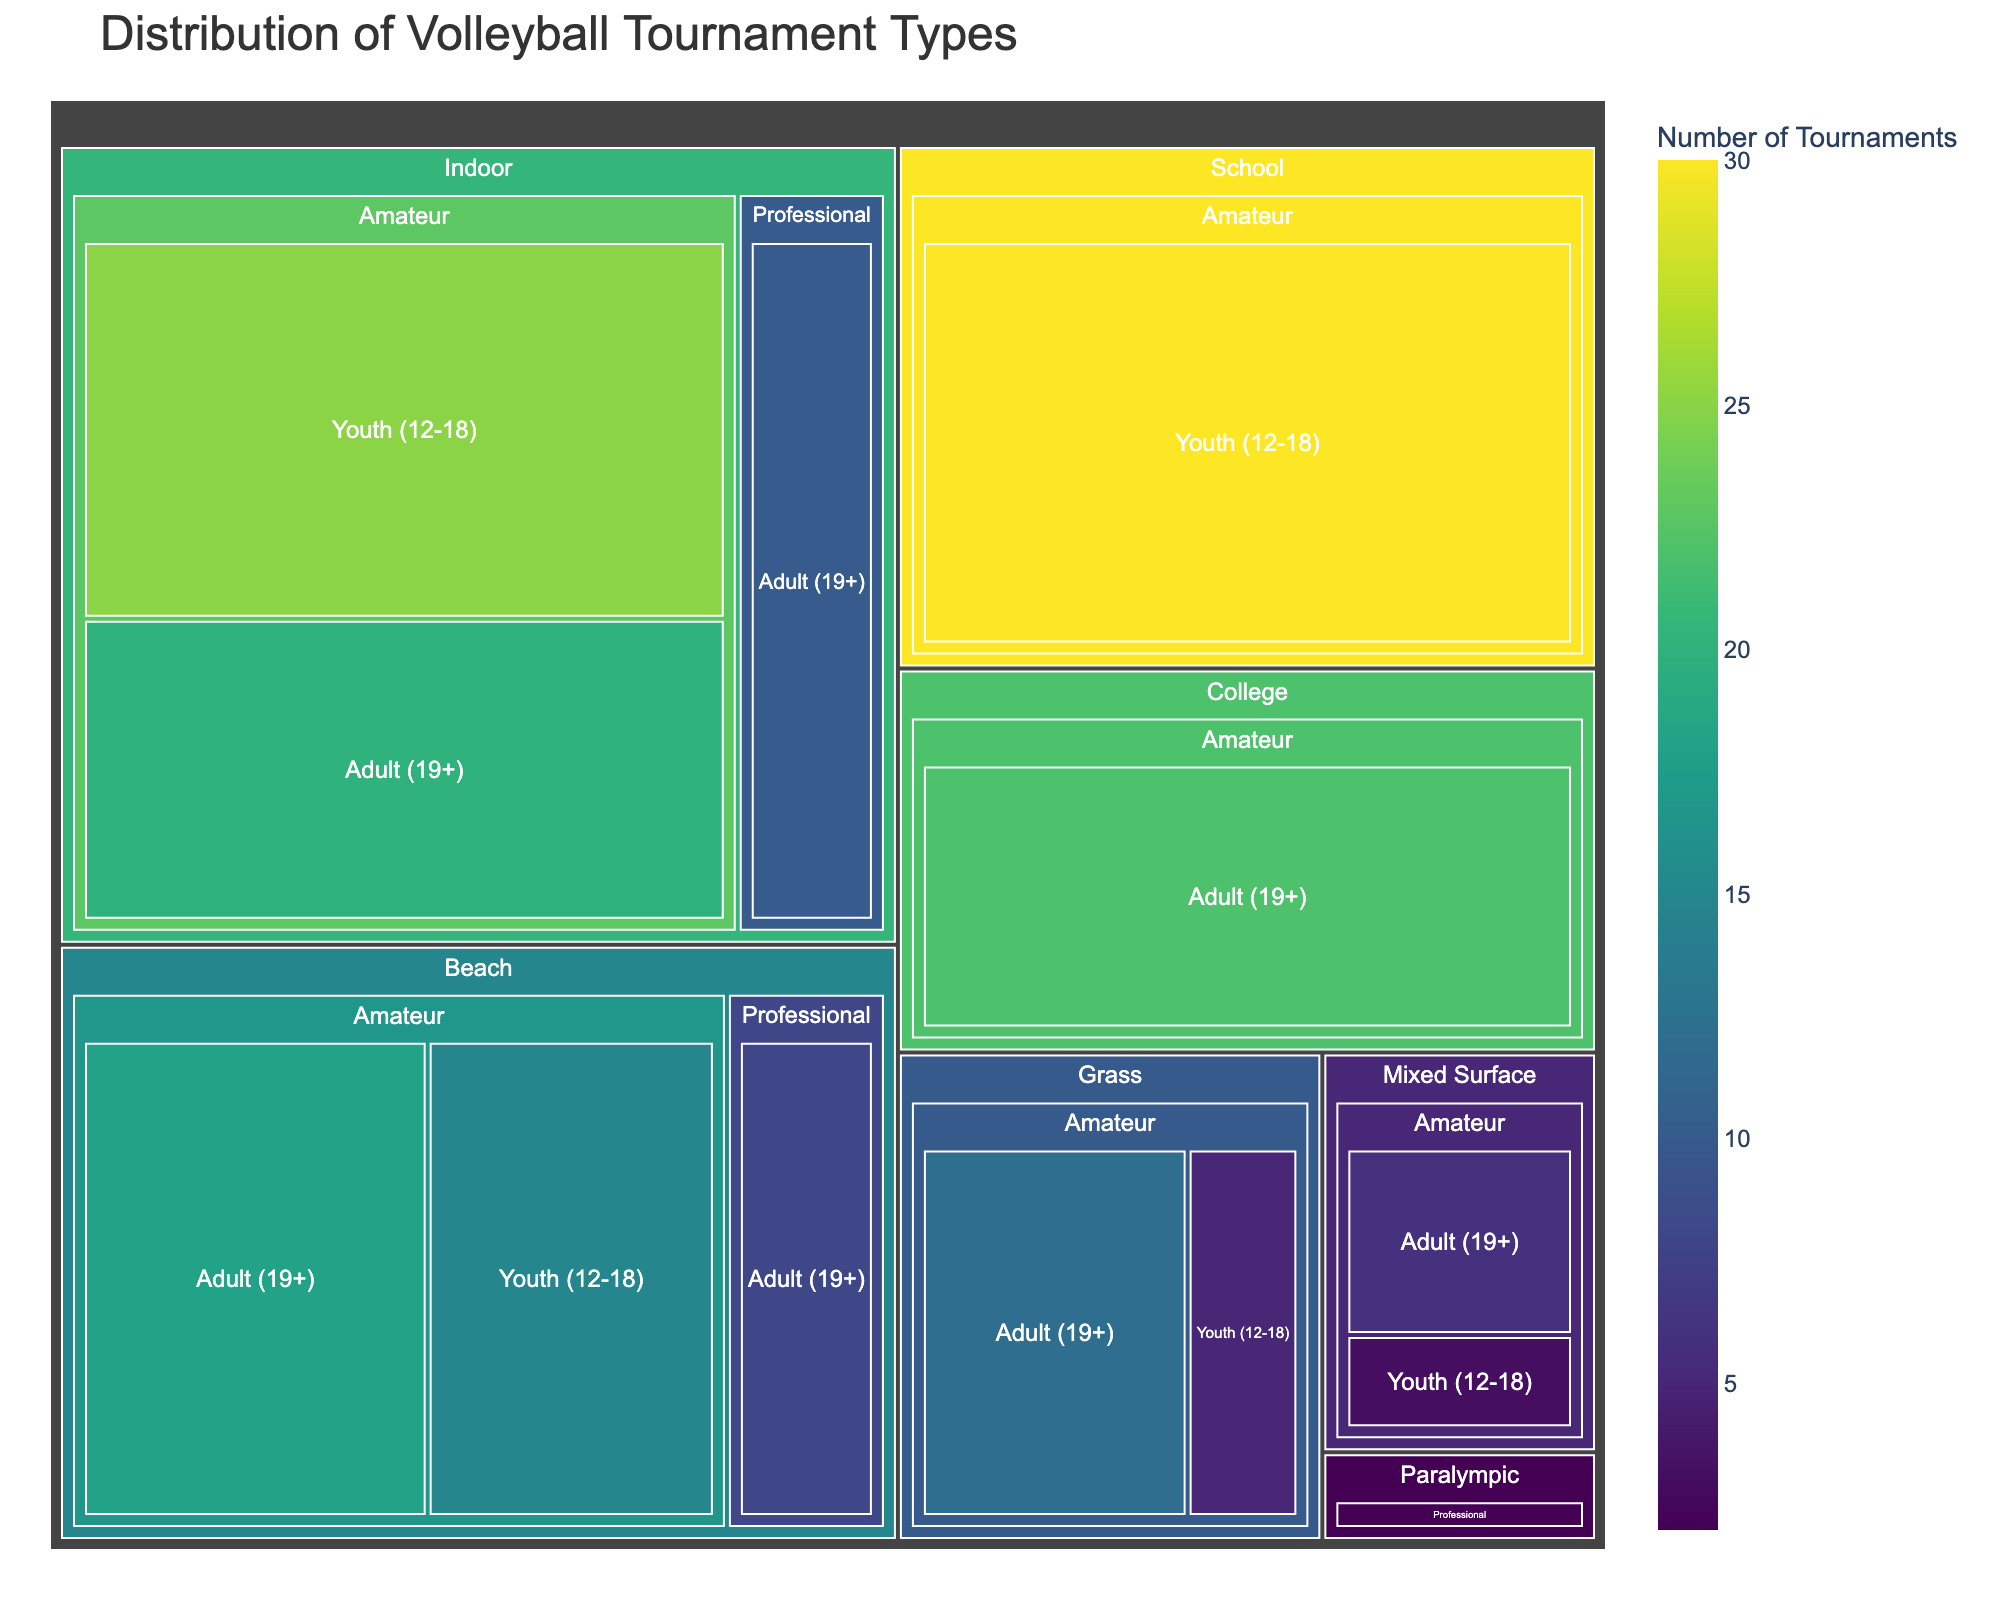What is the title of the figure? The title of the figure is usually displayed prominently at the top and serves to give an overview of what the figure represents. In this case, it can be directly read from the top of the figure.
Answer: Distribution of Volleyball Tournament Types Which age group has the highest number of tournaments for Indoor Amateur type? To find this, locate the "Indoor" section, then find the "Amateur" subsection and check the "Number of Tournaments" for both "Youth (12-18)" and "Adult (19+)". Compare the numbers.
Answer: Youth (12-18) What is the total number of Professional tournaments across all types? Sum the number of Professional tournaments for each type. Look at all sections (Indoor, Beach, Paralympic) that have "Professional" and add their values. Calculation: Indoor (10) + Beach (8) + Paralympic (2) = 20.
Answer: 20 Which participation level has the most number of tournaments overall? Sum the number of tournaments for each participation level across all tournament types and age groups. Compare the totals for "Amateur" and "Professional". The figure shows more extensive "Amateur" tournaments distributed across various types.
Answer: Amateur How many tournaments are held in Mixed Surface for Youth (12-18)? Locate the "Mixed Surface" section, find the "Amateur" subsection, and check the value for "Youth (12-18)".
Answer: 3 Which tournament type has the fewest tournaments in total? Sum the number of tournaments for each tournament type across all participation levels and age groups. Compare the totals for all types. "Mixed Surface" has the fewest when examined by visual size and absolute numbers. Calculation: 3 (Youth) + 6 (Adult) = 9.
Answer: Mixed Surface How many more tournaments are held for Beach Amateur Adults compared to Beach Professional Adults? Locate the "Beach" section, then compare the "Amateur Adults" (18) to "Professional Adults" (8). Subtract to find the difference. Calculation: 18 - 8 = 10.
Answer: 10 What is the distribution of tournaments for the "Paralympic" type? Locate the "Paralympic" section and check the values for "Adult" under the "Professional" subsection. It's the only available category under Paralympic.
Answer: 2 tournaments, Professional, Adult (19+) Which age group has the least tournaments in Grass type? Locate the "Grass" section, then find the values for "Youth (12-18)" and "Adult (19+)" under the "Amateur" subsection. Compare the numbers.
Answer: Youth (12-18) How many tournaments in total are held for Youth (12-18) across all types? Sum the number of tournaments for "Youth (12-18)" in all tournament types. Calculation: Indoor (25) + Beach (15) + Grass (5) + Mixed Surface (3) + School (30) = 78.
Answer: 78 